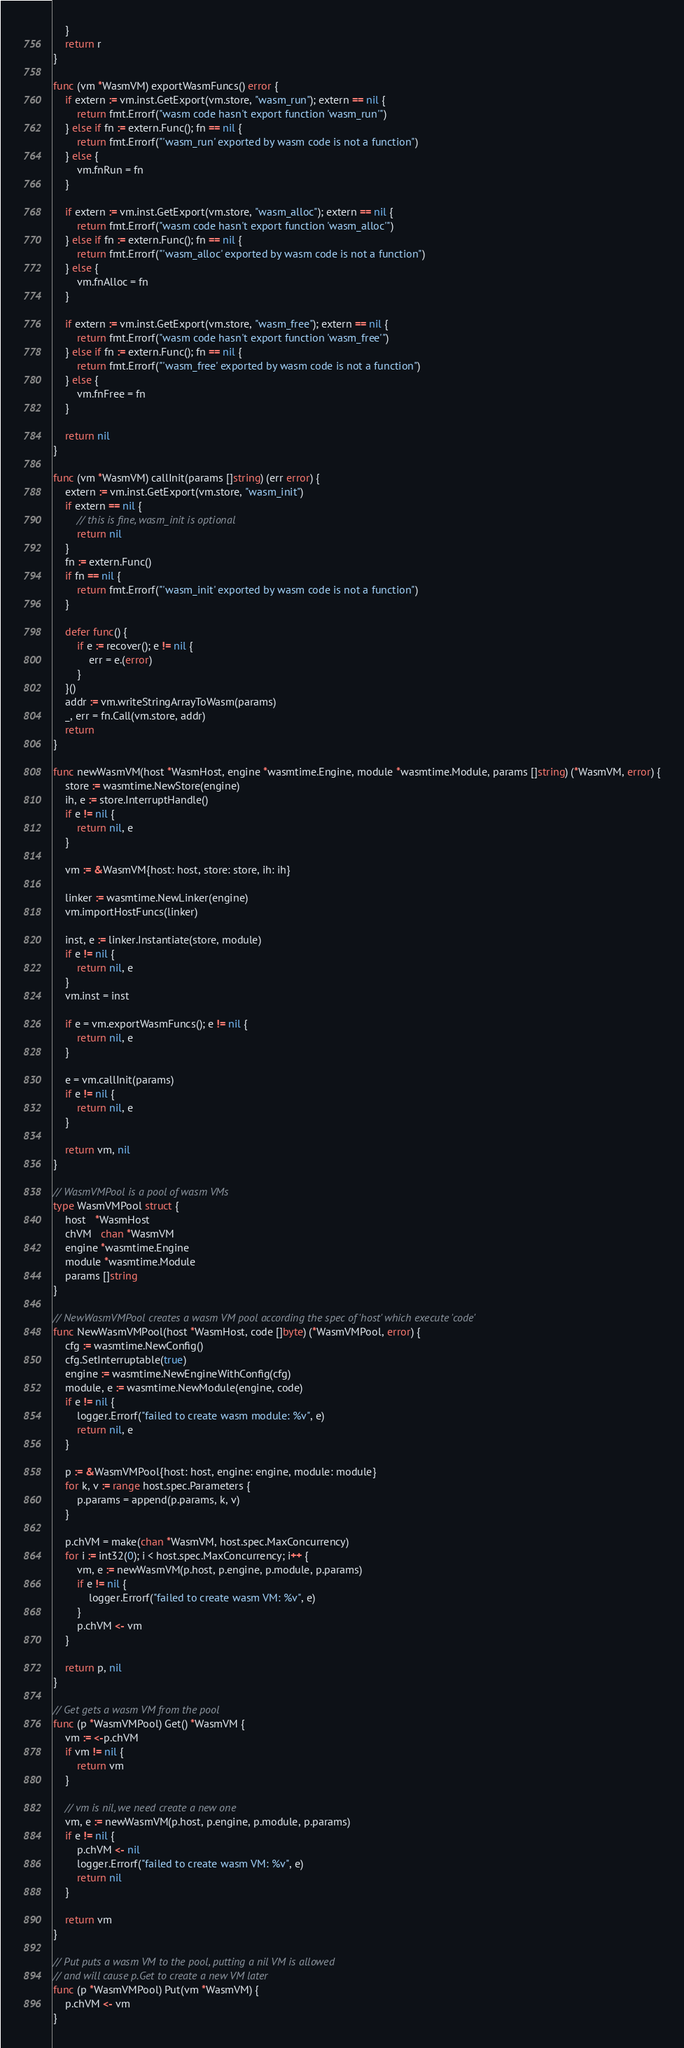Convert code to text. <code><loc_0><loc_0><loc_500><loc_500><_Go_>	}
	return r
}

func (vm *WasmVM) exportWasmFuncs() error {
	if extern := vm.inst.GetExport(vm.store, "wasm_run"); extern == nil {
		return fmt.Errorf("wasm code hasn't export function 'wasm_run'")
	} else if fn := extern.Func(); fn == nil {
		return fmt.Errorf("'wasm_run' exported by wasm code is not a function")
	} else {
		vm.fnRun = fn
	}

	if extern := vm.inst.GetExport(vm.store, "wasm_alloc"); extern == nil {
		return fmt.Errorf("wasm code hasn't export function 'wasm_alloc'")
	} else if fn := extern.Func(); fn == nil {
		return fmt.Errorf("'wasm_alloc' exported by wasm code is not a function")
	} else {
		vm.fnAlloc = fn
	}

	if extern := vm.inst.GetExport(vm.store, "wasm_free"); extern == nil {
		return fmt.Errorf("wasm code hasn't export function 'wasm_free'")
	} else if fn := extern.Func(); fn == nil {
		return fmt.Errorf("'wasm_free' exported by wasm code is not a function")
	} else {
		vm.fnFree = fn
	}

	return nil
}

func (vm *WasmVM) callInit(params []string) (err error) {
	extern := vm.inst.GetExport(vm.store, "wasm_init")
	if extern == nil {
		// this is fine, wasm_init is optional
		return nil
	}
	fn := extern.Func()
	if fn == nil {
		return fmt.Errorf("'wasm_init' exported by wasm code is not a function")
	}

	defer func() {
		if e := recover(); e != nil {
			err = e.(error)
		}
	}()
	addr := vm.writeStringArrayToWasm(params)
	_, err = fn.Call(vm.store, addr)
	return
}

func newWasmVM(host *WasmHost, engine *wasmtime.Engine, module *wasmtime.Module, params []string) (*WasmVM, error) {
	store := wasmtime.NewStore(engine)
	ih, e := store.InterruptHandle()
	if e != nil {
		return nil, e
	}

	vm := &WasmVM{host: host, store: store, ih: ih}

	linker := wasmtime.NewLinker(engine)
	vm.importHostFuncs(linker)

	inst, e := linker.Instantiate(store, module)
	if e != nil {
		return nil, e
	}
	vm.inst = inst

	if e = vm.exportWasmFuncs(); e != nil {
		return nil, e
	}

	e = vm.callInit(params)
	if e != nil {
		return nil, e
	}

	return vm, nil
}

// WasmVMPool is a pool of wasm VMs
type WasmVMPool struct {
	host   *WasmHost
	chVM   chan *WasmVM
	engine *wasmtime.Engine
	module *wasmtime.Module
	params []string
}

// NewWasmVMPool creates a wasm VM pool according the spec of 'host' which execute 'code'
func NewWasmVMPool(host *WasmHost, code []byte) (*WasmVMPool, error) {
	cfg := wasmtime.NewConfig()
	cfg.SetInterruptable(true)
	engine := wasmtime.NewEngineWithConfig(cfg)
	module, e := wasmtime.NewModule(engine, code)
	if e != nil {
		logger.Errorf("failed to create wasm module: %v", e)
		return nil, e
	}

	p := &WasmVMPool{host: host, engine: engine, module: module}
	for k, v := range host.spec.Parameters {
		p.params = append(p.params, k, v)
	}

	p.chVM = make(chan *WasmVM, host.spec.MaxConcurrency)
	for i := int32(0); i < host.spec.MaxConcurrency; i++ {
		vm, e := newWasmVM(p.host, p.engine, p.module, p.params)
		if e != nil {
			logger.Errorf("failed to create wasm VM: %v", e)
		}
		p.chVM <- vm
	}

	return p, nil
}

// Get gets a wasm VM from the pool
func (p *WasmVMPool) Get() *WasmVM {
	vm := <-p.chVM
	if vm != nil {
		return vm
	}

	// vm is nil, we need create a new one
	vm, e := newWasmVM(p.host, p.engine, p.module, p.params)
	if e != nil {
		p.chVM <- nil
		logger.Errorf("failed to create wasm VM: %v", e)
		return nil
	}

	return vm
}

// Put puts a wasm VM to the pool, putting a nil VM is allowed
// and will cause p.Get to create a new VM later
func (p *WasmVMPool) Put(vm *WasmVM) {
	p.chVM <- vm
}
</code> 